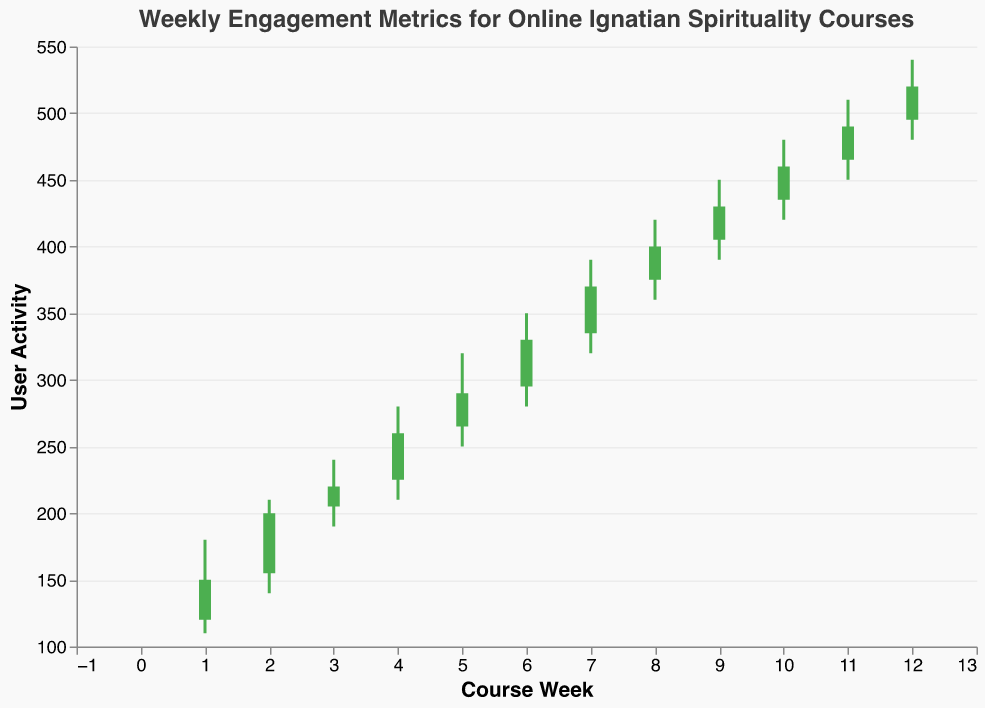**Basic Question:**
What is the highest user activity recorded in any week? The highest activity recorded is the peak value in the "High" column from week 1 to week 12. By examining the data, the highest value is 540 in week 12.
Answer: 540 **Basic Question:**
How many weeks are displayed in the figure? The x-axis represents the weeks and shows the range from 1 to 12, indicating there are 12 weeks displayed in the figure.
Answer: 12 **Compositional Question:**
What’s the average opening user activity for weeks 1 through 6? To find the average opening activity for the first 6 weeks, add the opening values for weeks 1 through 6 and divide by 6. \( (120 + 155 + 205 + 225 + 265 + 295) / 6 = 1265 / 6 = 210.83 \)
Answer: 210.83 **Comparison Question:**
Which week has the highest increase in user activity from open to close? To determine the week with the highest increase, calculate the difference between the close and open values for each week and find the maximum. Week 12 has the highest difference of \( 520 - 495 = 25 \), which is the maximum increase.
Answer: Week 12 **Chart-Type Specific Question:**
During which week did the user activity show the least fluctuation? Fluctuation can be understood as the range between the high and low values of each week. By examining the "High" and "Low" values, Week 3 had the smallest range: \( 240 - 190 = 50 \).
Answer: Week 3 **Basic Question:**
What is the title of the figure? The title of the figure is specified as "Weekly Engagement Metrics for Online Ignatian Spirituality Courses".
Answer: Weekly Engagement Metrics for Online Ignatian Spirituality Courses **Compositional Question:**
What is the total low user activity for all weeks? Sum the low values from week 1 to week 12. \( 110 + 140 + 190 + 210 + 250 + 280 + 320 + 360 + 390 + 420 + 450 + 480 = 4300 \).
Answer: 4300 **Comparison Question:**
Which week showed a decline in user activity from open to close? Weeks where the close value is less than the open value indicate a decline. Comparing open and close values reveals that Week 1 had a decline (\( 150 < 120 \)).
Answer: Week 1 **Chart-Type Specific Question:**
Which week had the widest range of user activity? The week with the widest range can be found by identifying the week with the highest span between the high and low values. Week 12 had the largest range of activity: \( 540 - 480 = 60 \).
Answer: Week 12 